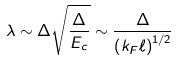Convert formula to latex. <formula><loc_0><loc_0><loc_500><loc_500>\lambda \sim \Delta \sqrt { \frac { \Delta } { E _ { c } } } \sim \frac { \Delta } { \left ( k _ { F } \ell \right ) ^ { 1 / 2 } }</formula> 